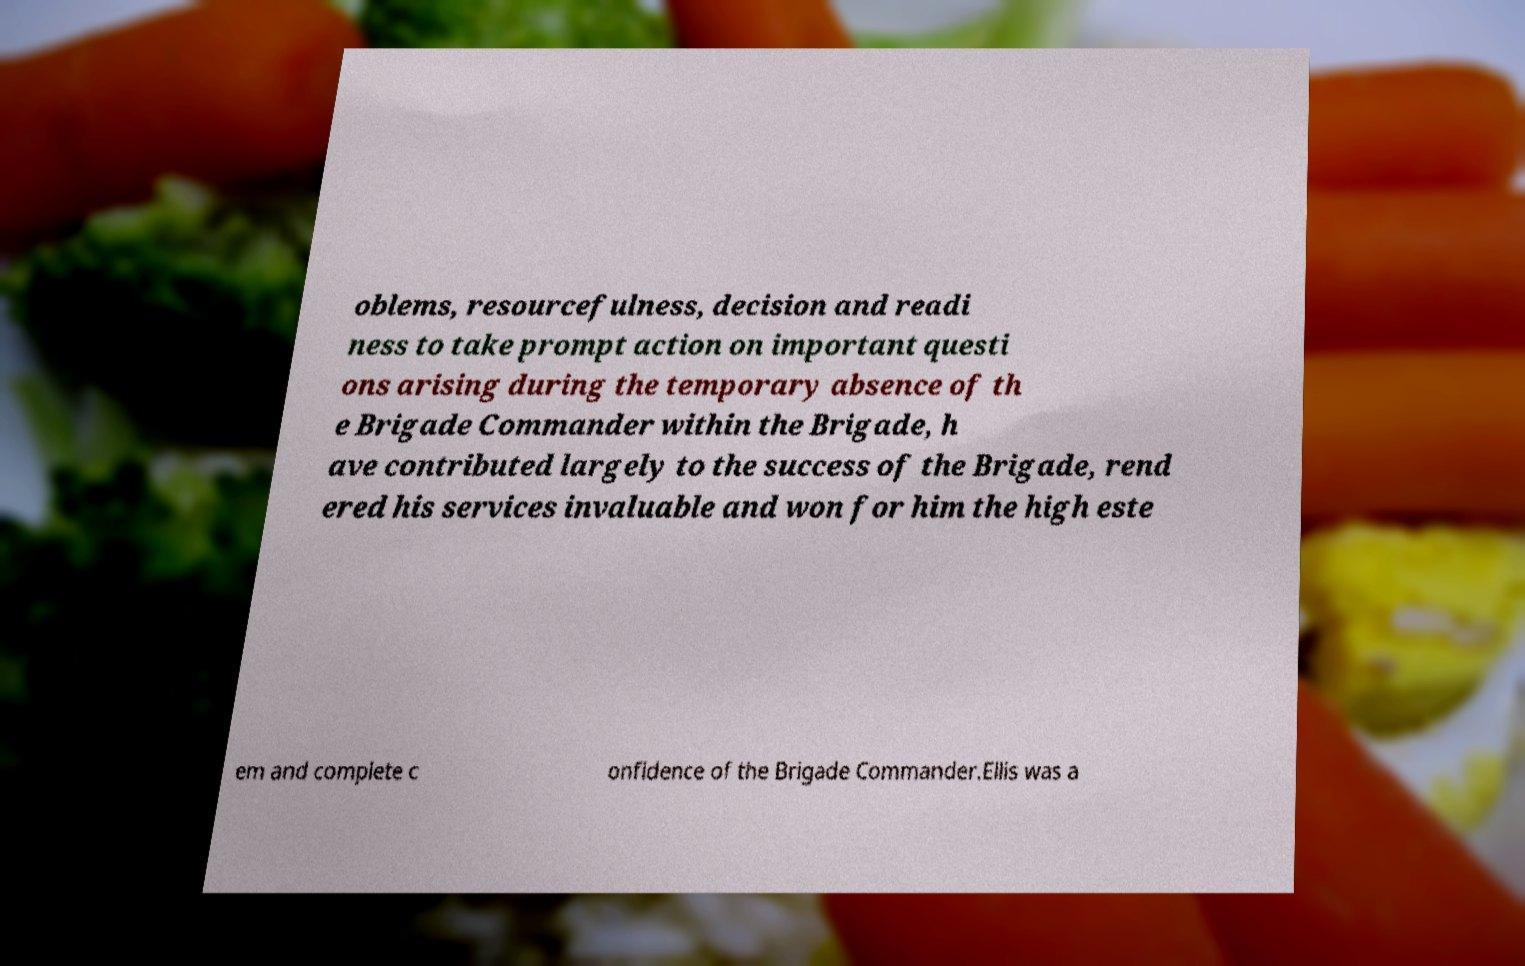For documentation purposes, I need the text within this image transcribed. Could you provide that? oblems, resourcefulness, decision and readi ness to take prompt action on important questi ons arising during the temporary absence of th e Brigade Commander within the Brigade, h ave contributed largely to the success of the Brigade, rend ered his services invaluable and won for him the high este em and complete c onfidence of the Brigade Commander.Ellis was a 